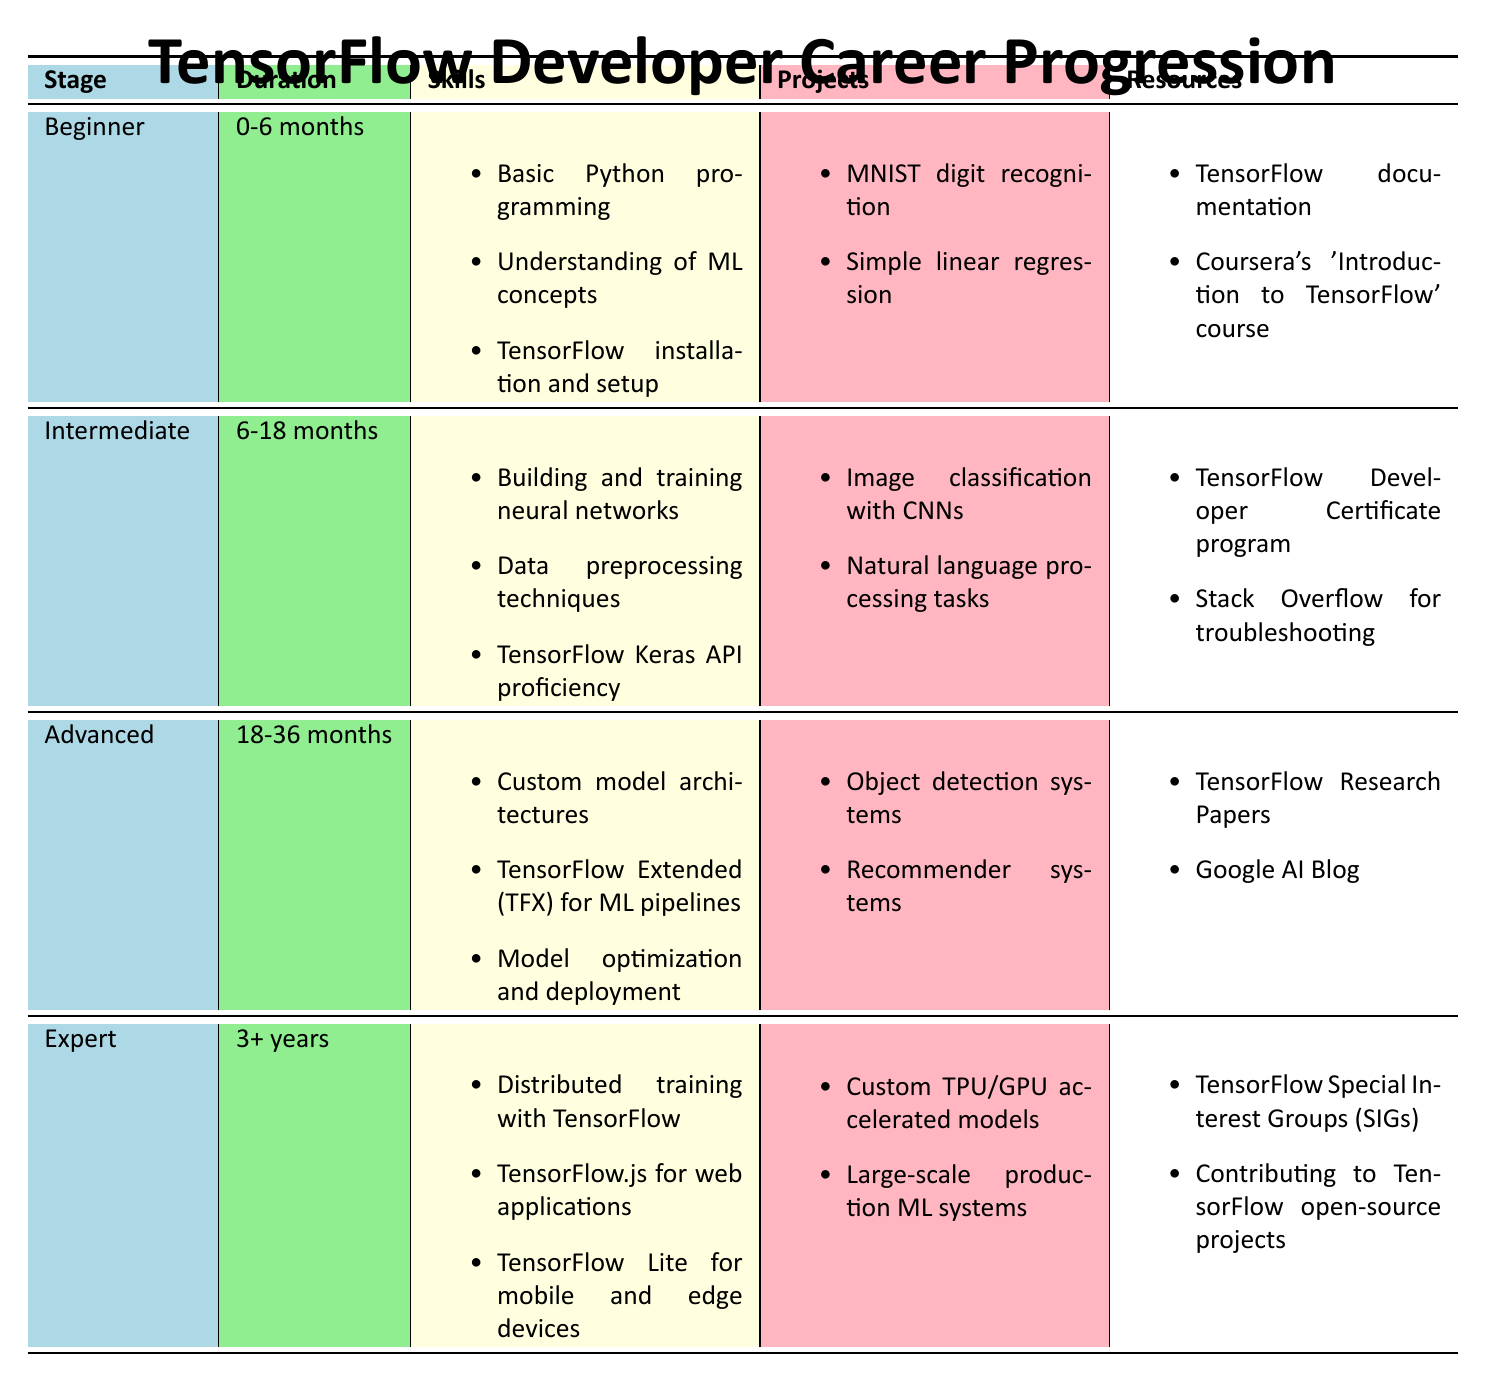What skills are required for the Beginner stage? The Beginner stage lists three skills: Basic Python programming, Understanding of machine learning concepts, and TensorFlow installation and setup.
Answer: Basic Python programming, Understanding of machine learning concepts, TensorFlow installation and setup How long does it take to progress from Intermediate to Advanced? The Intermediate stage lasts from 6 to 18 months and the Advanced stage spans from 18 to 36 months. This means it takes 36 - 18 = 18 months to progress from Intermediate to Advanced.
Answer: 18 months Are there any machine learning concepts mentioned in the resources for the Advanced stage? The resources for the Advanced stage include TensorFlow Research Papers and Google AI Blog, both of which are related to machine learning concepts.
Answer: Yes Which stage includes skills related to mobile and edge devices? The Expert stage includes skills such as TensorFlow Lite for mobile and edge devices.
Answer: Expert stage What is the average duration across all stages? The durations are as follows: Beginner (6 months), Intermediate (12 months), Advanced (18 months), and Expert (3 years, or 36 months). We convert all to months: 6, 12, 18, and 36. The total is 6 + 12 + 18 + 36 = 72 months, and the average is 72 / 4 = 18 months.
Answer: 18 months Is TensorFlow Keras API proficiency required at the Intermediate stage? The Intermediate stage specifically lists TensorFlow Keras API proficiency as one of the required skills.
Answer: Yes What projects are associated with the Advanced stage? The Advanced stage lists two projects: Object detection systems and Recommender systems.
Answer: Object detection systems, Recommender systems What resources are provided for the Beginner stage? The Beginner stage lists: TensorFlow documentation and Coursera's 'Introduction to TensorFlow' course as resources.
Answer: TensorFlow documentation, Coursera's 'Introduction to TensorFlow' course 